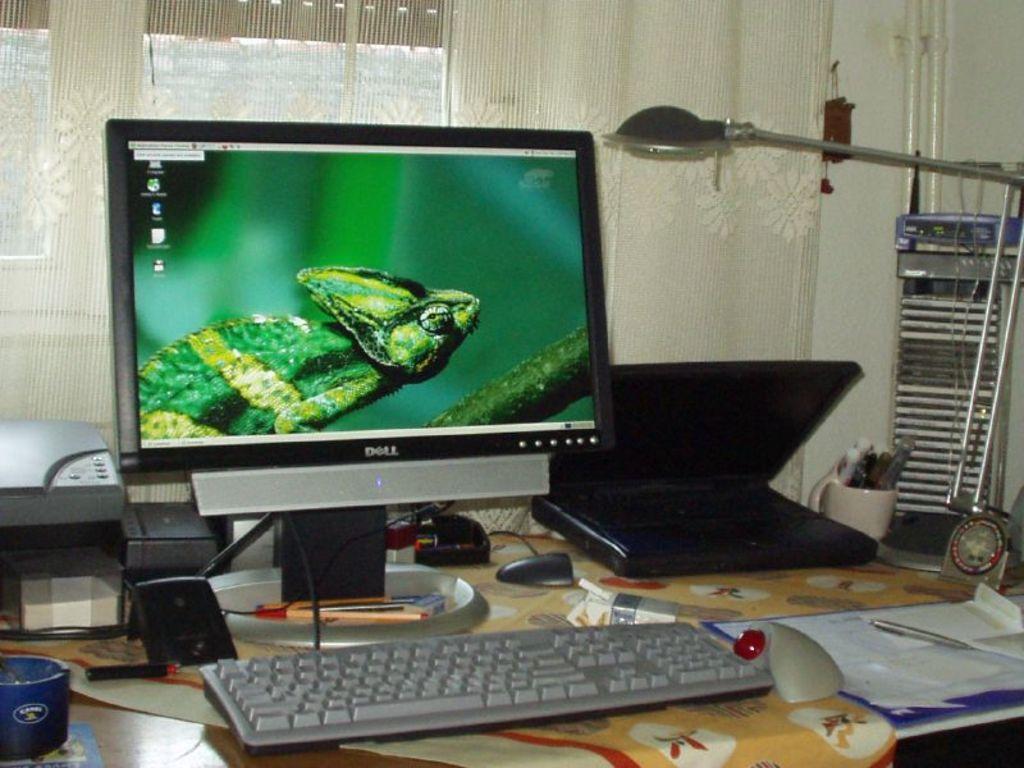Who made the computer screen shown?
Keep it short and to the point. Dell. 